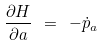<formula> <loc_0><loc_0><loc_500><loc_500>\frac { \partial H } { \partial a } \ = \ - \dot { p } _ { a }</formula> 